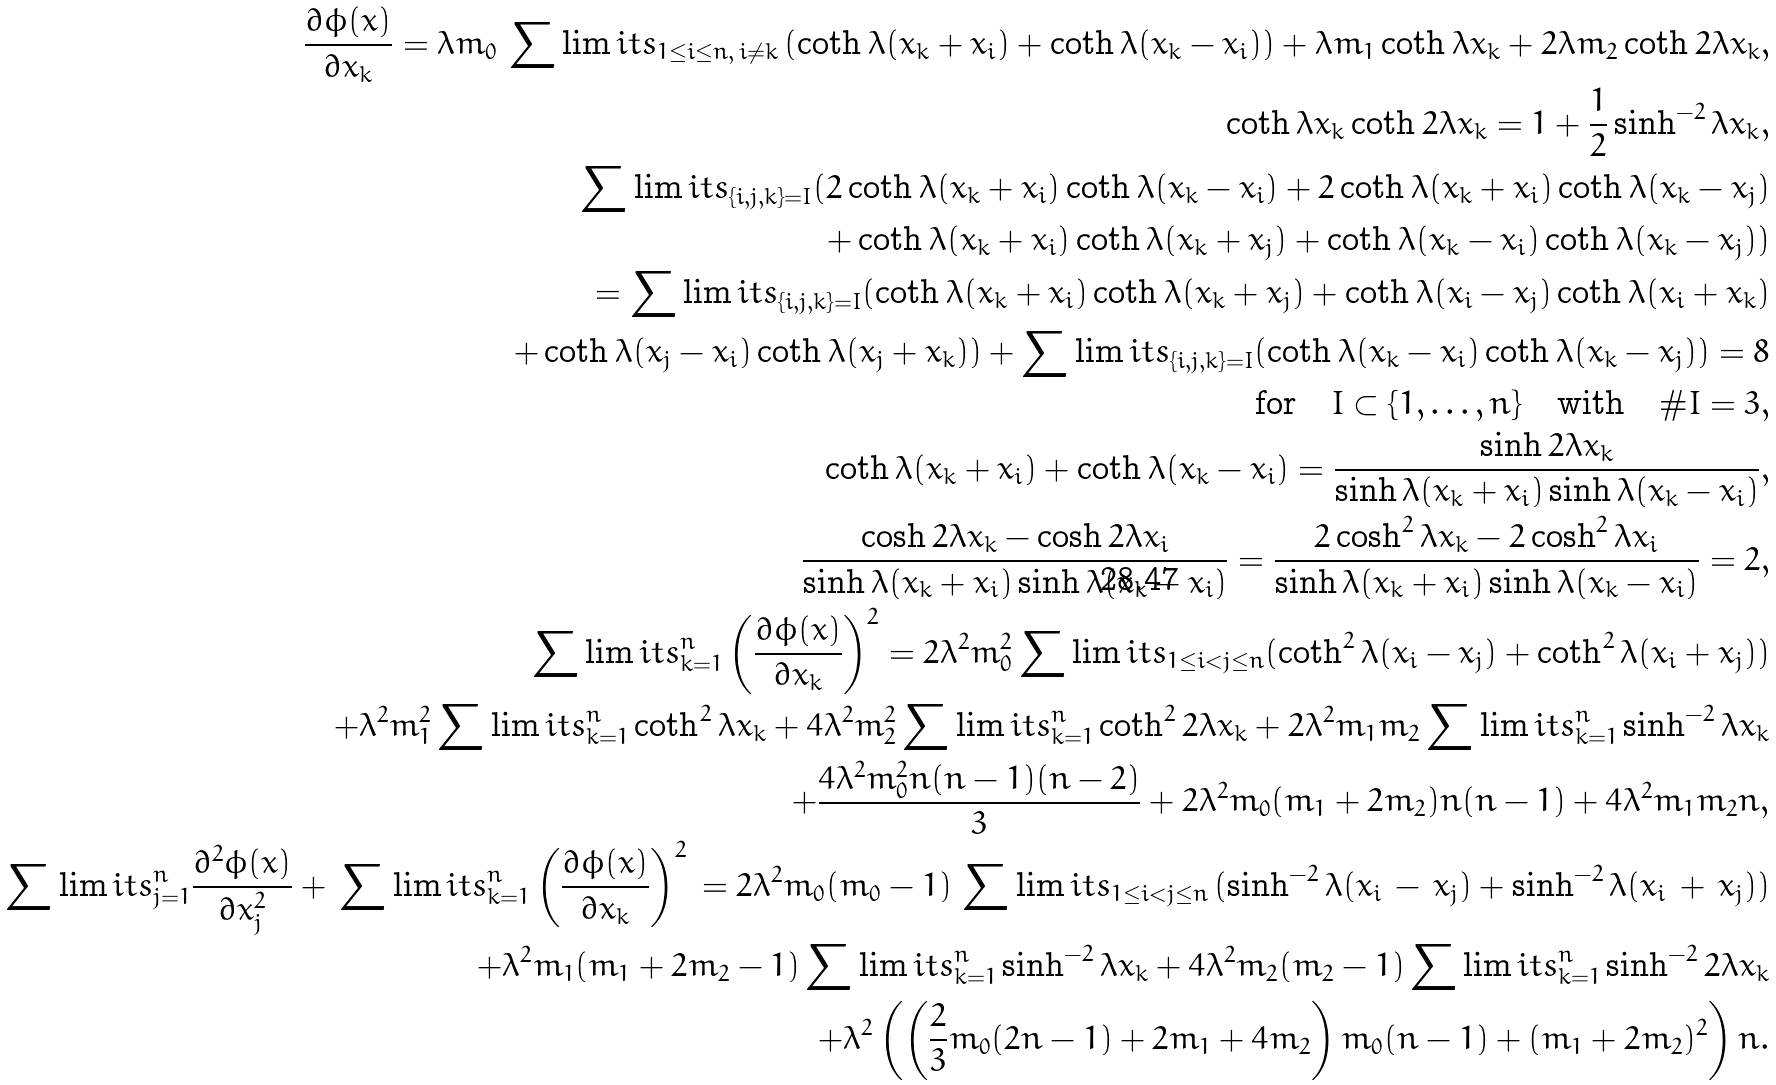Convert formula to latex. <formula><loc_0><loc_0><loc_500><loc_500>\frac { \partial \phi ( x ) } { \partial x _ { k } } = \lambda m _ { 0 } \, \sum \lim i t s _ { 1 \leq i \leq n , \, i \ne k } \, ( \coth \lambda ( x _ { k } + x _ { i } ) + \coth \lambda ( x _ { k } - x _ { i } ) ) + \lambda m _ { 1 } \coth \lambda x _ { k } + 2 \lambda m _ { 2 } \coth 2 \lambda x _ { k } , \\ \coth \lambda x _ { k } \coth 2 \lambda x _ { k } = 1 + \frac { 1 } { 2 } \sinh ^ { - 2 } \lambda x _ { k } , \\ \sum \lim i t s _ { \{ i , j , k \} = I } ( 2 \coth \lambda ( x _ { k } + x _ { i } ) \coth \lambda ( x _ { k } - x _ { i } ) + 2 \coth \lambda ( x _ { k } + x _ { i } ) \coth \lambda ( x _ { k } - x _ { j } ) \\ + \coth \lambda ( x _ { k } + x _ { i } ) \coth \lambda ( x _ { k } + x _ { j } ) + \coth \lambda ( x _ { k } - x _ { i } ) \coth \lambda ( x _ { k } - x _ { j } ) ) \\ = \sum \lim i t s _ { \{ i , j , k \} = I } ( \coth \lambda ( x _ { k } + x _ { i } ) \coth \lambda ( x _ { k } + x _ { j } ) + \coth \lambda ( x _ { i } - x _ { j } ) \coth \lambda ( x _ { i } + x _ { k } ) \\ + \coth \lambda ( x _ { j } - x _ { i } ) \coth \lambda ( x _ { j } + x _ { k } ) ) + \sum \lim i t s _ { \{ i , j , k \} = I } ( \coth \lambda ( x _ { k } - x _ { i } ) \coth \lambda ( x _ { k } - x _ { j } ) ) = 8 \\ \text {for} \quad I \subset \{ 1 , \dots , n \} \quad \text {with} \quad \# I = 3 , \\ \coth \lambda ( x _ { k } + x _ { i } ) + \coth \lambda ( x _ { k } - x _ { i } ) = \frac { \sinh 2 \lambda x _ { k } } { \sinh \lambda ( x _ { k } + x _ { i } ) \sinh \lambda ( x _ { k } - x _ { i } ) } , \\ \frac { \cosh 2 \lambda x _ { k } - \cosh 2 \lambda x _ { i } } { \sinh \lambda ( x _ { k } + x _ { i } ) \sinh \lambda ( x _ { k } - x _ { i } ) } = \frac { 2 \cosh ^ { 2 } \lambda x _ { k } - 2 \cosh ^ { 2 } \lambda x _ { i } } { \sinh \lambda ( x _ { k } + x _ { i } ) \sinh \lambda ( x _ { k } - x _ { i } ) } = 2 , \\ \sum \lim i t s _ { k = 1 } ^ { n } \left ( \frac { \partial \phi ( x ) } { \partial x _ { k } } \right ) ^ { 2 } = 2 \lambda ^ { 2 } m _ { 0 } ^ { 2 } \sum \lim i t s _ { 1 \leq i < j \leq n } ( \coth ^ { 2 } \lambda ( x _ { i } - x _ { j } ) + \coth ^ { 2 } \lambda ( x _ { i } + x _ { j } ) ) \\ + \lambda ^ { 2 } m _ { 1 } ^ { 2 } \sum \lim i t s _ { k = 1 } ^ { n } \coth ^ { 2 } \lambda x _ { k } + 4 \lambda ^ { 2 } m _ { 2 } ^ { 2 } \sum \lim i t s _ { k = 1 } ^ { n } \coth ^ { 2 } 2 \lambda x _ { k } + 2 \lambda ^ { 2 } m _ { 1 } m _ { 2 } \sum \lim i t s _ { k = 1 } ^ { n } \sinh ^ { - 2 } \lambda x _ { k } \\ + \frac { 4 \lambda ^ { 2 } m _ { 0 } ^ { 2 } n ( n - 1 ) ( n - 2 ) } { 3 } + 2 \lambda ^ { 2 } m _ { 0 } ( m _ { 1 } + 2 m _ { 2 } ) n ( n - 1 ) + 4 \lambda ^ { 2 } m _ { 1 } m _ { 2 } n , \\ \sum \lim i t s _ { j = 1 } ^ { n } \frac { \partial ^ { 2 } \phi ( x ) } { \partial x _ { j } ^ { 2 } } + \, \sum \lim i t s _ { k = 1 } ^ { n } \left ( \frac { \partial \phi ( x ) } { \partial x _ { k } } \right ) ^ { 2 } \, = 2 \lambda ^ { 2 } m _ { 0 } ( m _ { 0 } - 1 ) \, \sum \lim i t s _ { 1 \leq i < j \leq n } \, ( \sinh ^ { - 2 } \lambda ( x _ { i } \, - \, x _ { j } ) + \sinh ^ { - 2 } \lambda ( x _ { i } \, + \, x _ { j } ) ) \\ + \lambda ^ { 2 } m _ { 1 } ( m _ { 1 } + 2 m _ { 2 } - 1 ) \sum \lim i t s _ { k = 1 } ^ { n } \sinh ^ { - 2 } \lambda x _ { k } + 4 \lambda ^ { 2 } m _ { 2 } ( m _ { 2 } - 1 ) \sum \lim i t s _ { k = 1 } ^ { n } \sinh ^ { - 2 } 2 \lambda x _ { k } \\ + \lambda ^ { 2 } \left ( \left ( \frac { 2 } { 3 } m _ { 0 } ( 2 n - 1 ) + 2 m _ { 1 } + 4 m _ { 2 } \right ) m _ { 0 } ( n - 1 ) + ( m _ { 1 } + 2 m _ { 2 } ) ^ { 2 } \right ) n .</formula> 